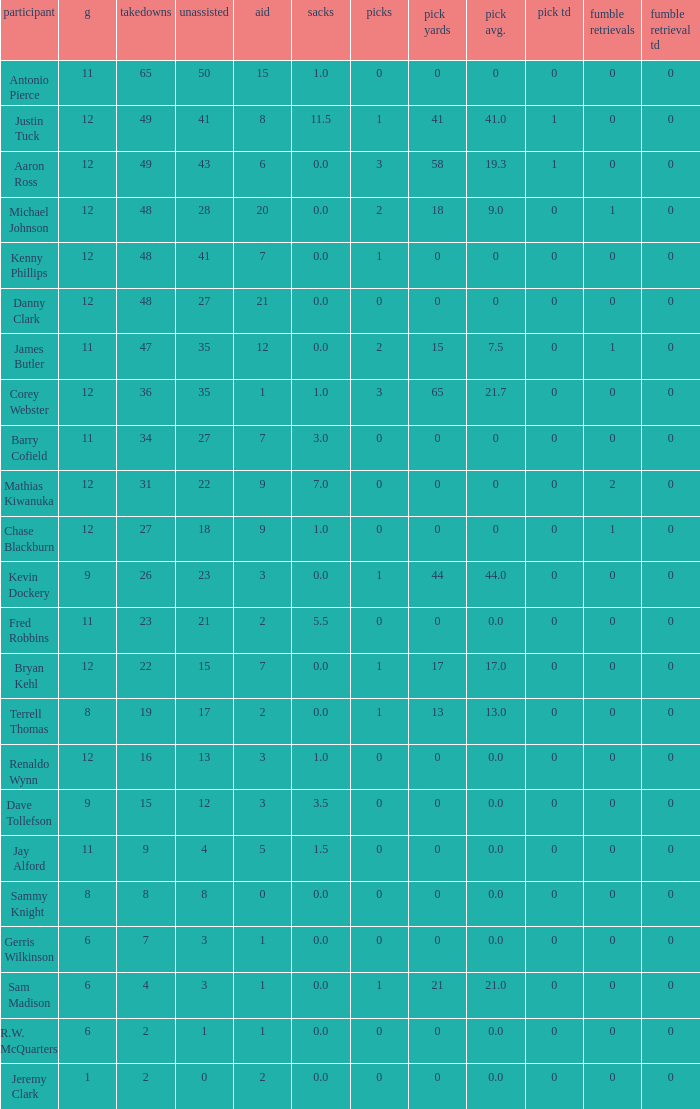Mention the lowest fum rec td. 0.0. 